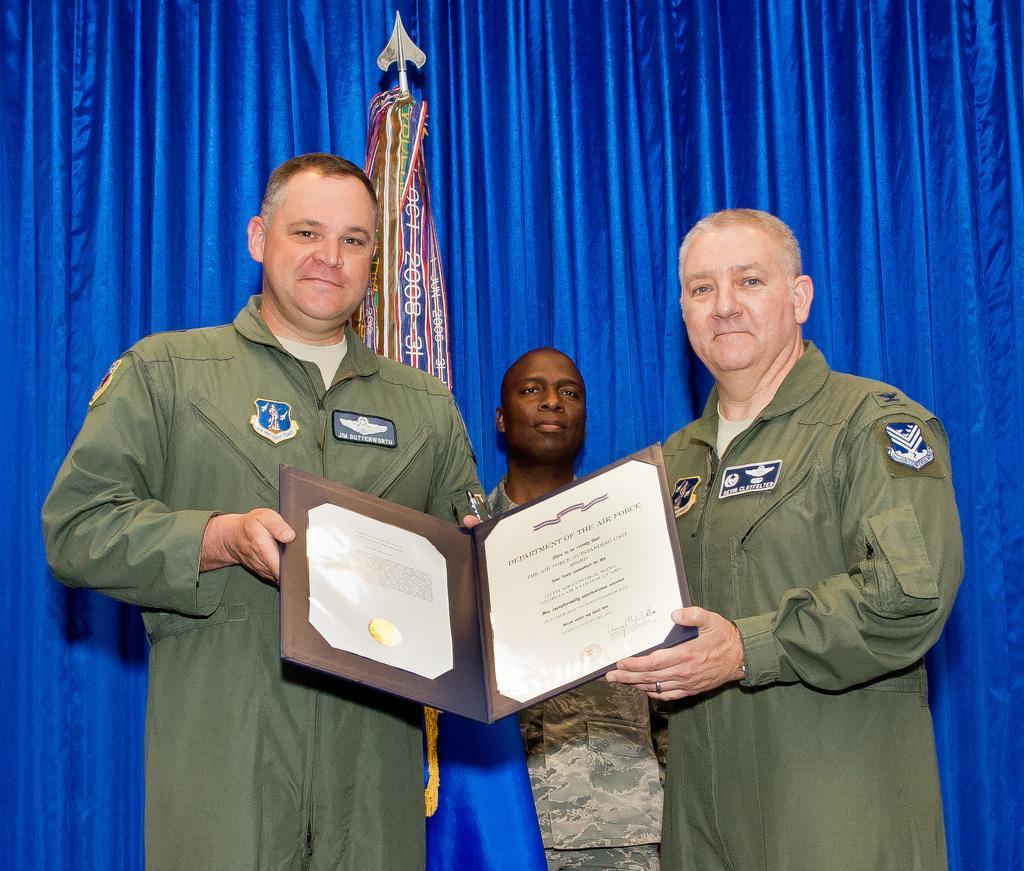Describe this image in one or two sentences. In this picture I can see couple of men standing and looks like they are holding a certificate and I can see another man standing in the back and I can see flag and a blue color cloth in the background. 